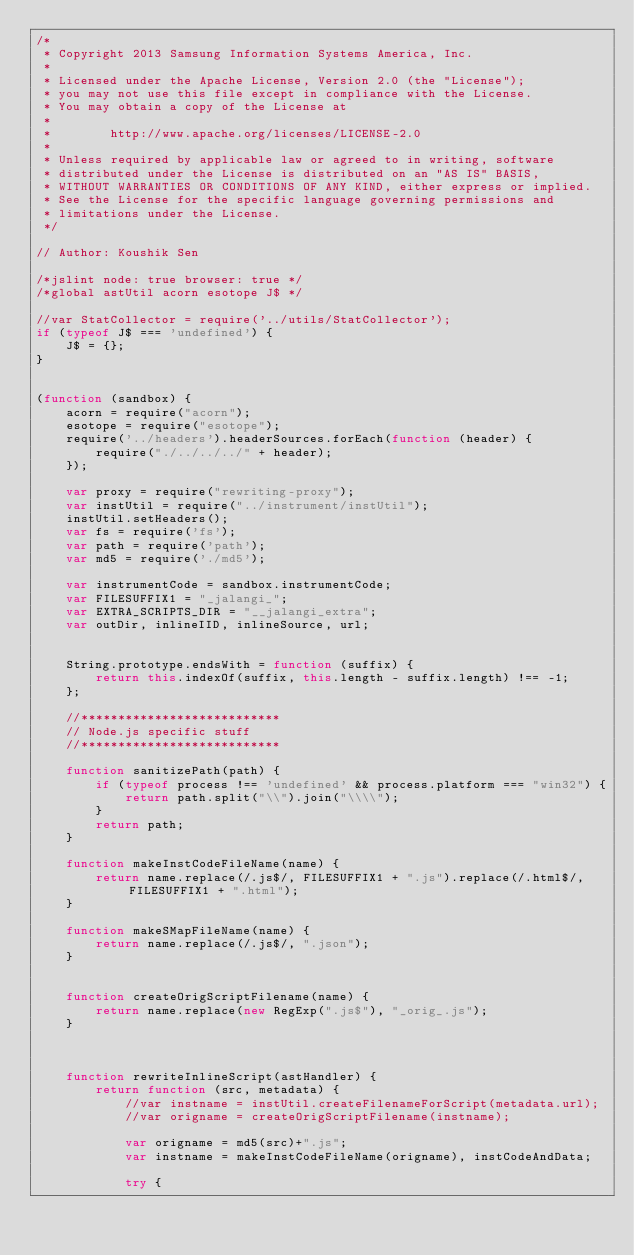Convert code to text. <code><loc_0><loc_0><loc_500><loc_500><_JavaScript_>/*
 * Copyright 2013 Samsung Information Systems America, Inc.
 *
 * Licensed under the Apache License, Version 2.0 (the "License");
 * you may not use this file except in compliance with the License.
 * You may obtain a copy of the License at
 *
 *        http://www.apache.org/licenses/LICENSE-2.0
 *
 * Unless required by applicable law or agreed to in writing, software
 * distributed under the License is distributed on an "AS IS" BASIS,
 * WITHOUT WARRANTIES OR CONDITIONS OF ANY KIND, either express or implied.
 * See the License for the specific language governing permissions and
 * limitations under the License.
 */

// Author: Koushik Sen

/*jslint node: true browser: true */
/*global astUtil acorn esotope J$ */

//var StatCollector = require('../utils/StatCollector');
if (typeof J$ === 'undefined') {
    J$ = {};
}


(function (sandbox) {
    acorn = require("acorn");
    esotope = require("esotope");
    require('../headers').headerSources.forEach(function (header) {
        require("./../../../" + header);
    });

    var proxy = require("rewriting-proxy");
    var instUtil = require("../instrument/instUtil");
    instUtil.setHeaders();
    var fs = require('fs');
    var path = require('path');
    var md5 = require('./md5');

    var instrumentCode = sandbox.instrumentCode;
    var FILESUFFIX1 = "_jalangi_";
    var EXTRA_SCRIPTS_DIR = "__jalangi_extra";
    var outDir, inlineIID, inlineSource, url;


    String.prototype.endsWith = function (suffix) {
        return this.indexOf(suffix, this.length - suffix.length) !== -1;
    };

    //***************************
    // Node.js specific stuff
    //***************************

    function sanitizePath(path) {
        if (typeof process !== 'undefined' && process.platform === "win32") {
            return path.split("\\").join("\\\\");
        }
        return path;
    }

    function makeInstCodeFileName(name) {
        return name.replace(/.js$/, FILESUFFIX1 + ".js").replace(/.html$/, FILESUFFIX1 + ".html");
    }

    function makeSMapFileName(name) {
        return name.replace(/.js$/, ".json");
    }


    function createOrigScriptFilename(name) {
        return name.replace(new RegExp(".js$"), "_orig_.js");
    }



    function rewriteInlineScript(astHandler) {
        return function (src, metadata) {
            //var instname = instUtil.createFilenameForScript(metadata.url);
            //var origname = createOrigScriptFilename(instname);

            var origname = md5(src)+".js";
            var instname = makeInstCodeFileName(origname), instCodeAndData;

            try {</code> 